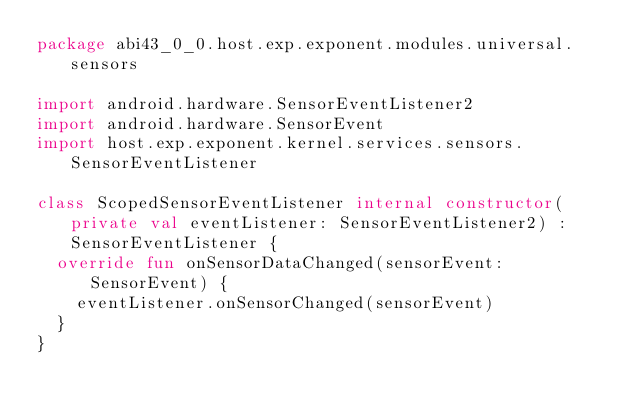<code> <loc_0><loc_0><loc_500><loc_500><_Kotlin_>package abi43_0_0.host.exp.exponent.modules.universal.sensors

import android.hardware.SensorEventListener2
import android.hardware.SensorEvent
import host.exp.exponent.kernel.services.sensors.SensorEventListener

class ScopedSensorEventListener internal constructor(private val eventListener: SensorEventListener2) : SensorEventListener {
  override fun onSensorDataChanged(sensorEvent: SensorEvent) {
    eventListener.onSensorChanged(sensorEvent)
  }
}
</code> 